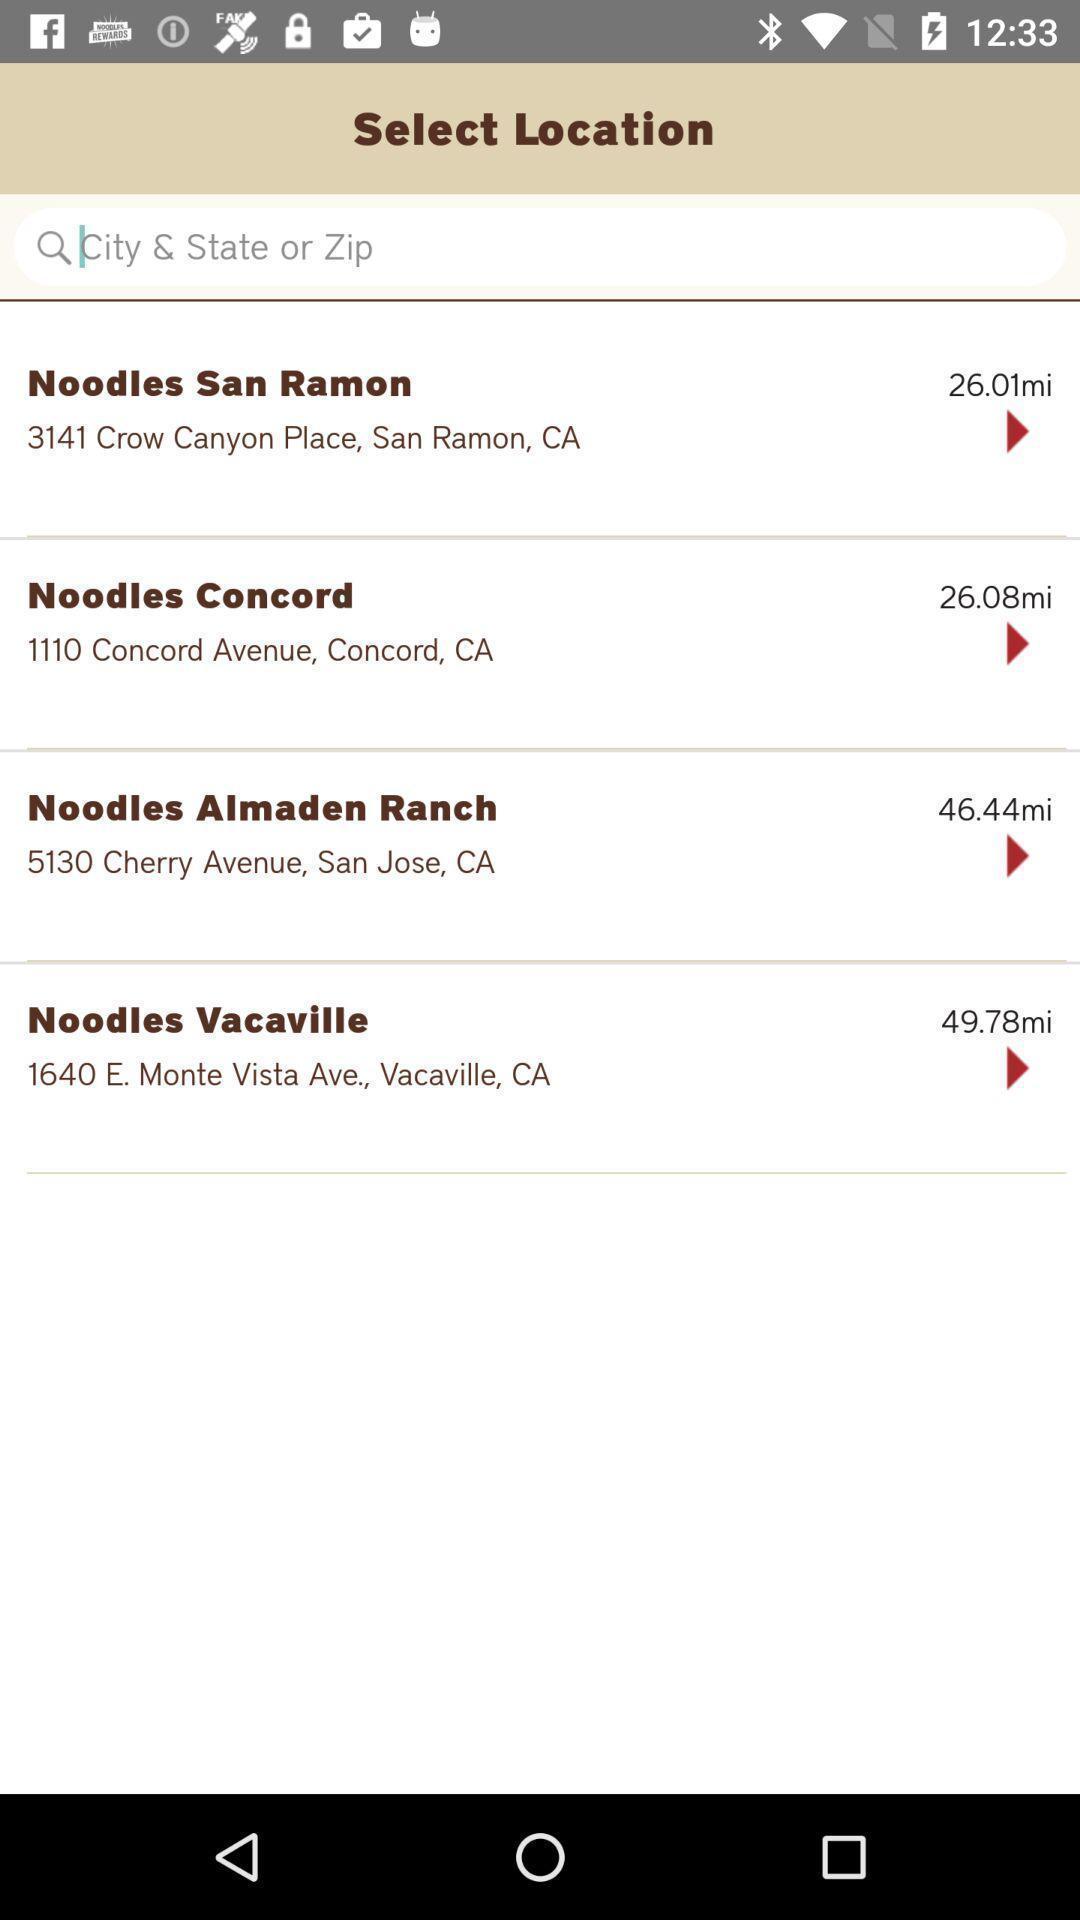Explain what's happening in this screen capture. Page showing select location with search bar. 